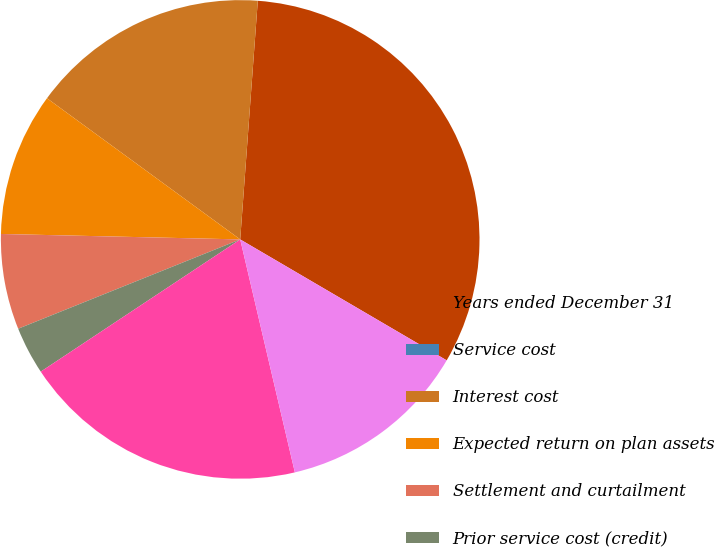Convert chart to OTSL. <chart><loc_0><loc_0><loc_500><loc_500><pie_chart><fcel>Years ended December 31<fcel>Service cost<fcel>Interest cost<fcel>Expected return on plan assets<fcel>Settlement and curtailment<fcel>Prior service cost (credit)<fcel>Net actuarial losses<fcel>Net periodic cost<nl><fcel>32.26%<fcel>0.0%<fcel>16.13%<fcel>9.68%<fcel>6.45%<fcel>3.23%<fcel>19.35%<fcel>12.9%<nl></chart> 